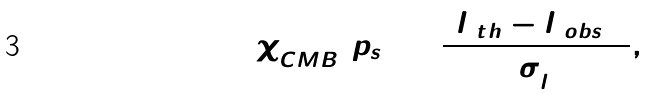Convert formula to latex. <formula><loc_0><loc_0><loc_500><loc_500>\chi _ { C M B } ^ { 2 } ( p _ { s } ) = \frac { ( l _ { 1 t h } - l _ { 1 o b s } ) ^ { 2 } } { \sigma _ { l } ^ { 2 } } ,</formula> 